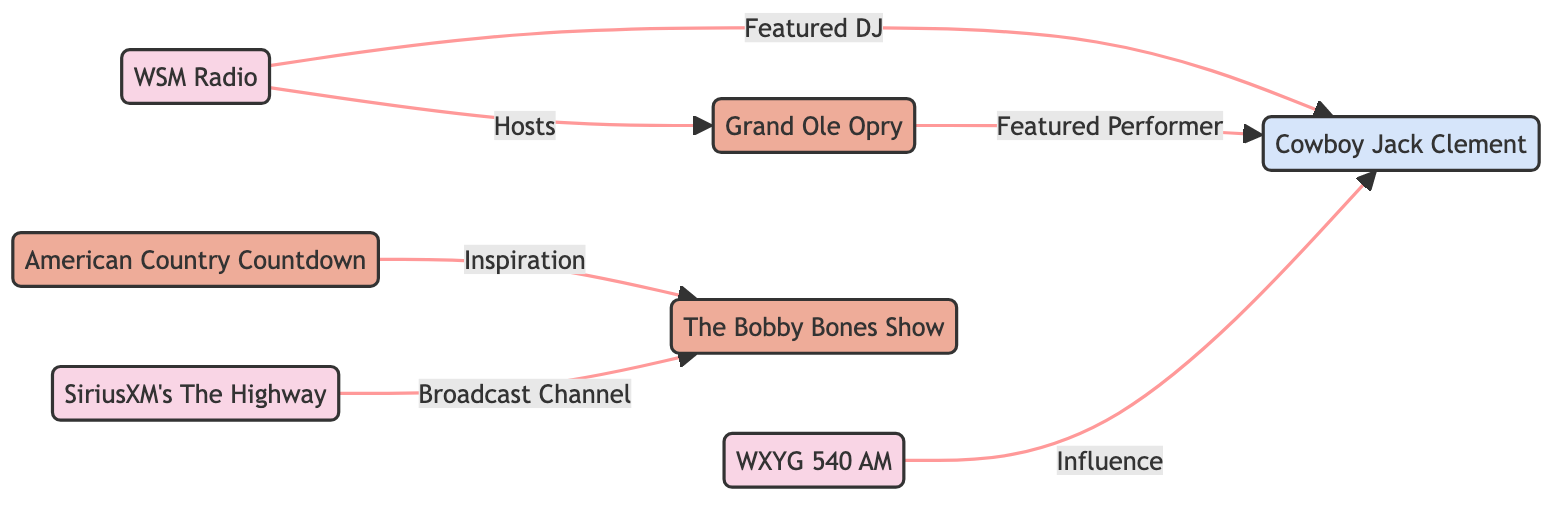What is the role of WSM Radio in relation to the Grand Ole Opry? The diagram indicates that WSM Radio "Hosts" the Grand Ole Opry. This relationship shows that WSM is responsible for broadcasting or facilitating the Opry's events.
Answer: Hosts How many nodes are in this network diagram? By counting the distinct entities represented in the diagram, we find there are seven nodes: WSM Radio, Grand Ole Opry, WXYG 540 AM, American Country Countdown, The Bobby Bones Show, SiriusXM's The Highway, and Cowboy Jack Clement.
Answer: Seven Which radio station is known for classic country programming? The diagram clearly identifies WXYG 540 AM as the station known for its deep cuts and classic country programming. This description directly links WXYG to classic country content.
Answer: WXYG 540 AM Who is the featured performer at the Grand Ole Opry? The connection between the Grand Ole Opry and Cowboy Jack Clement indicates that Cowboy Jack is a "Featured Performer" at the Opry. This relationship highlights his significant role in this iconic setting.
Answer: Cowboy Jack Clement In what way does American Country Countdown relate to The Bobby Bones Show? The diagram shows that American Country Countdown serves as an "Inspiration" for The Bobby Bones Show, indicating that the first program influences the content or style of the latter show.
Answer: Inspiration Which DJ is linked to WSM Radio as a featured element? The diagram connects Cowboy Jack Clement to WSM Radio, indicating he is a "Featured DJ." This signifies that Cowboy Jack has a notable role as a DJ on this radio station.
Answer: Cowboy Jack Clement How does SiriusXM connect to The Bobby Bones Show? The relationship depicted is that SiriusXM is a "Broadcast Channel" for The Bobby Bones Show. This means that the show is transmitted or aired through SiriusXM's platform.
Answer: Broadcast Channel What is the primary relationship between Cowboy Jack Clement and WXYG 540 AM? The diagram specifies that WXYG is influenced by Cowboy Jack Clement, indicating that his music or style has an impact on this radio station's programming choices.
Answer: Influence 